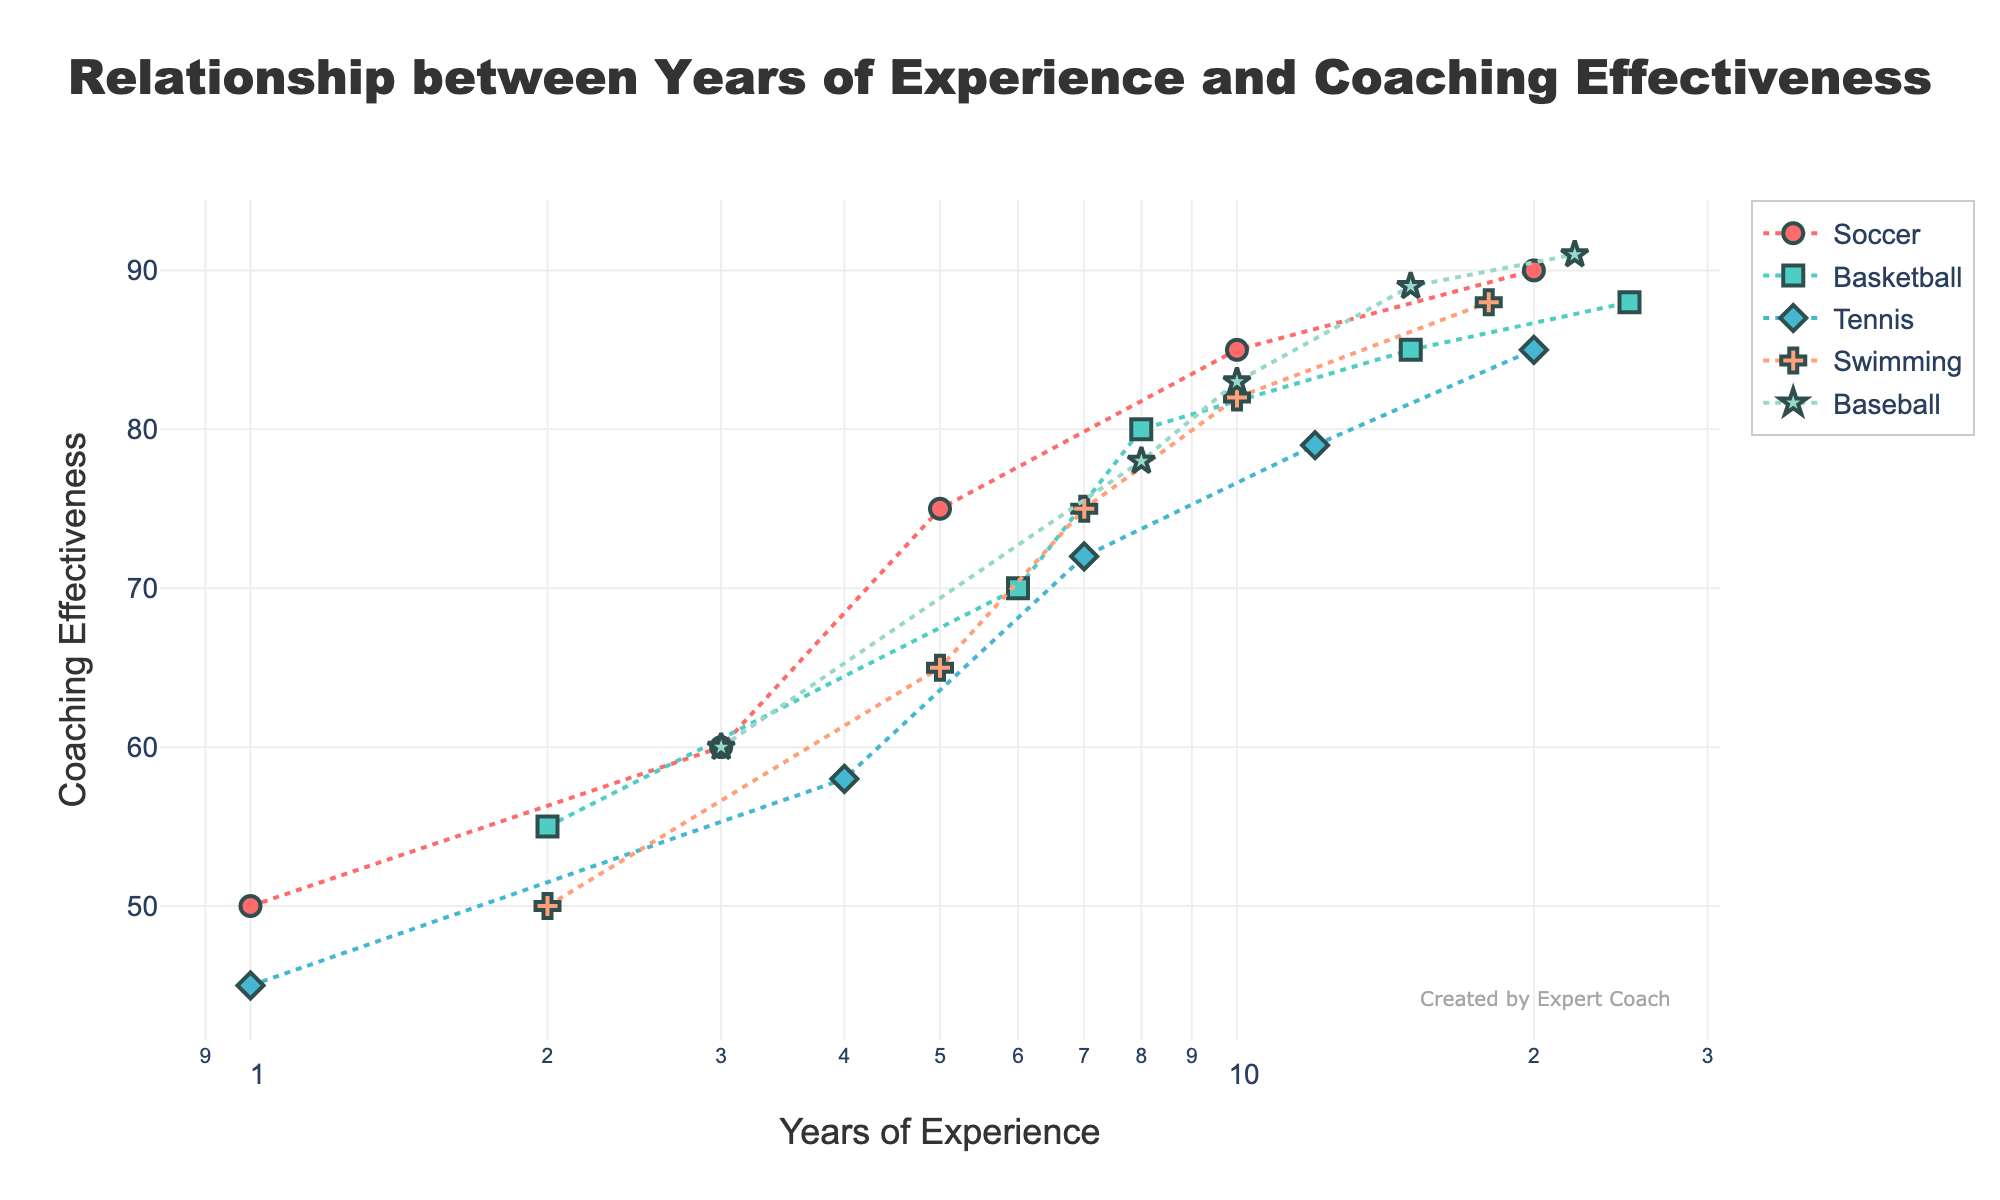How many sports are represented in the plot? Count the number of distinct sports listed in the legend of the plot, which are depicted by different markers and colors.
Answer: 5 What is the title of the plot? Read the title text located at the top center of the plot.
Answer: Relationship between Years of Experience and Coaching Effectiveness Which sport has the highest coaching effectiveness for 15 years of experience? Locate the data points for 15 years of experience on the x-axis and compare the y-values (coaching effectiveness) for each sport at this point.
Answer: Baseball What colors represent Soccer and Tennis? Look at the legend and identify the colors associated with Soccer and Tennis.
Answer: Soccer: #FF6B6B, Tennis: #45B7D1 Which sport shows the most significant increase in coaching effectiveness from 1 year to 20 years of experience? Calculate the difference in coaching effectiveness from 1 year to 20 years of experience for each sport and identify the sport with the greatest increase.
Answer: Soccer Compare the coaching effectiveness of Basketball and Swimming for coaches with 10 years of experience. Which sport shows higher effectiveness? Look at the data points corresponding to 10 years of experience for both Basketball and Swimming and compare their y-values.
Answer: Swimming What is the general trend of coaching effectiveness as years of experience increase? Observe the direction and steepness of the lines connecting the data points for each sport and describe the overall trend.
Answer: Increasing What is the coaching effectiveness for Tennis with 7 years of experience? Find the data point where Tennis correlates with 7 years of experience on the x-axis and read the corresponding y-value.
Answer: 72 Identify a sport and the corresponding years of experience where the coaching effectiveness remains consistent or shows minimal change. Look at each sport's line, assess the flatness or minimal slope, and identify the corresponding range of years.
Answer: Basketball, 15 to 25 years What kind of scale is used for the x-axis? Observe the labels and scale notations on the x-axis.
Answer: Log scale 